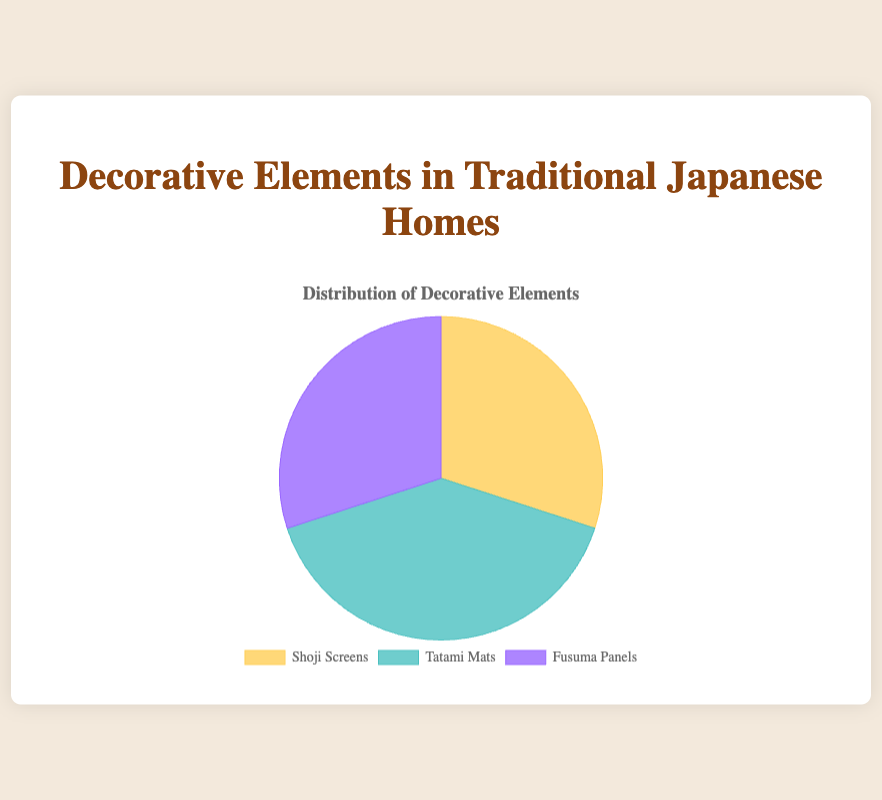Which decorative element has the largest percentage in traditional Japanese homes? By observing the pie chart, the segment representing "Tatami Mats" appears larger compared to the segments for "Shoji Screens" and "Fusuma Panels". Since its segment is visibly the largest, we conclude that "Tatami Mats" has the largest percentage.
Answer: Tatami Mats Comparing Shoji Screens and Fusuma Panels, which has the greater percentage? The pie chart shows the percentage data for each element. 'Shoji Screens' and 'Fusuma Panels' both have equal-sized segments. Verifying the data, Shoji Screens (30%) and Fusuma Panels (30%) have the same percentage.
Answer: Both are equal What is the combined percentage of Shoji Screens and Fusuma Panels? By looking at the pie chart, we can visually add the percentages for 'Shoji Screens' (30%) and 'Fusuma Panels' (30%). Therefore, the combined percentage is 30% + 30% = 60%.
Answer: 60% Which color represents Tatami Mats in the pie chart? By referring to the legend in the pie chart, 'Tatami Mats' corresponds to the segment colored in turquoise.
Answer: Turquoise What is the difference in percentage between Tatami Mats and Shoji Screens? From the pie chart, 'Tatami Mats' is at 40% and 'Shoji Screens' is at 30%. Therefore, the difference in percentage is 40% - 30% = 10%.
Answer: 10% Comparing Tatami Mats and Fusuma Panels, which has the smaller percentage? By observing the pie chart, 'Fusuma Panels' has a smaller segment size compared to 'Tatami Mats'. Verifying the data, Tatami Mats (40%) is greater than Fusuma Panels (30%). Thus, Fusuma Panels has the smaller percentage.
Answer: Fusuma Panels What percentage more are Tatami Mats than Fusuma Panels? Looking at the chart, 'Tatami Mats' is at 40% and 'Fusuma Panels' at 30%. The difference is calculated as 40% - 30% = 10%. So, Tatami Mats are 10% more than Fusuma Panels.
Answer: 10% more What percentage of the total do Tatami Mats and Shoji Screens together cover in the pie chart? The pie chart gives the information that 'Tatami Mats' is 40% and 'Shoji Screens' is 30%. Adding these together gives 40% + 30% = 70%.
Answer: 70% If you were to combine Shoji Screens and Fusuma Panels, would their total percentage exceed that of Tatami Mats? The combined percentages of 'Shoji Screens' (30%) and 'Fusuma Panels' (30%) sum up to 30% + 30% = 60%. This doesn't exceed the percentage of 'Tatami Mats', which is 40%.
Answer: No Which decorative element is represented by the color purple? By looking at the pie chart legend, the color purple corresponds to 'Fusuma Panels'.
Answer: Fusuma Panels 